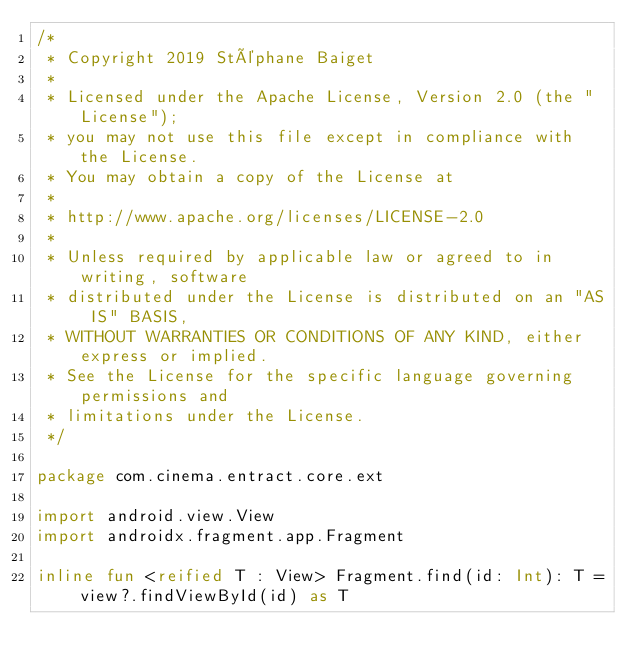Convert code to text. <code><loc_0><loc_0><loc_500><loc_500><_Kotlin_>/*
 * Copyright 2019 Stéphane Baiget
 *
 * Licensed under the Apache License, Version 2.0 (the "License");
 * you may not use this file except in compliance with the License.
 * You may obtain a copy of the License at
 *
 * http://www.apache.org/licenses/LICENSE-2.0
 *
 * Unless required by applicable law or agreed to in writing, software
 * distributed under the License is distributed on an "AS IS" BASIS,
 * WITHOUT WARRANTIES OR CONDITIONS OF ANY KIND, either express or implied.
 * See the License for the specific language governing permissions and
 * limitations under the License.
 */

package com.cinema.entract.core.ext

import android.view.View
import androidx.fragment.app.Fragment

inline fun <reified T : View> Fragment.find(id: Int): T = view?.findViewById(id) as T</code> 